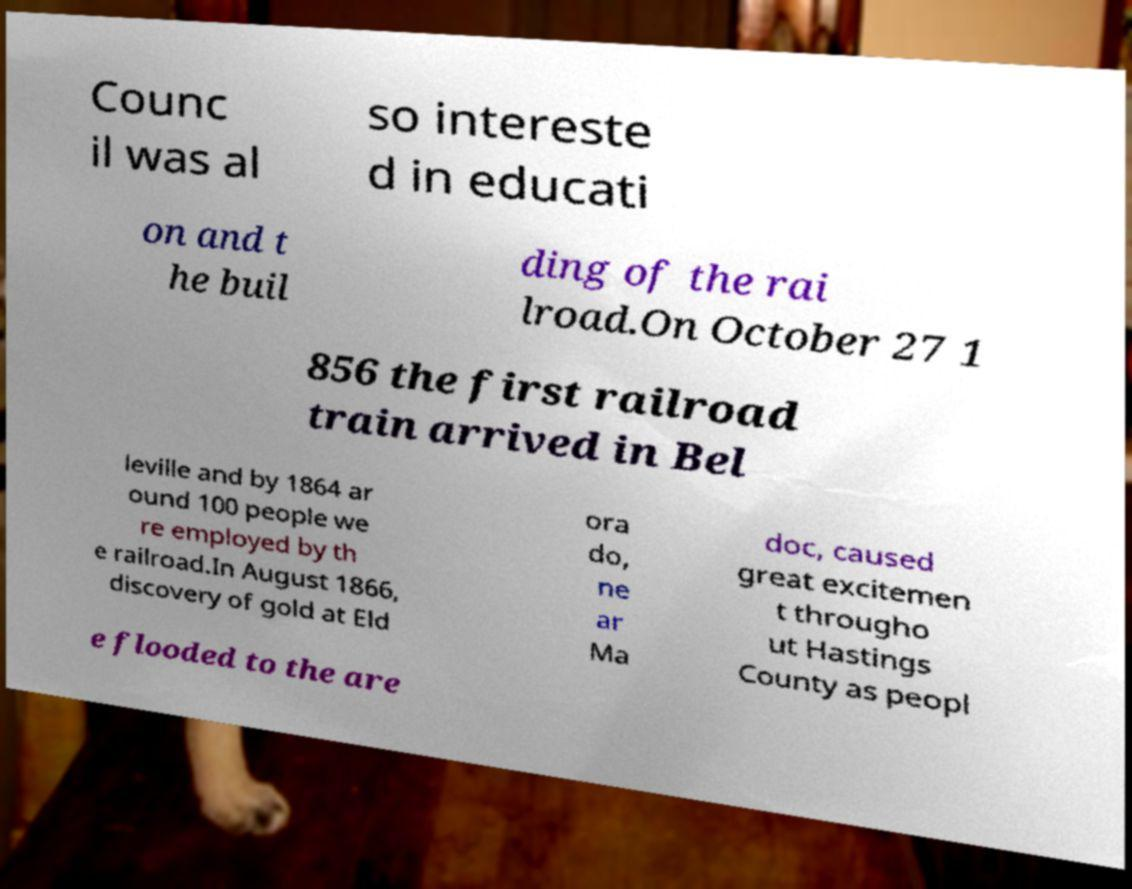Could you assist in decoding the text presented in this image and type it out clearly? Counc il was al so intereste d in educati on and t he buil ding of the rai lroad.On October 27 1 856 the first railroad train arrived in Bel leville and by 1864 ar ound 100 people we re employed by th e railroad.In August 1866, discovery of gold at Eld ora do, ne ar Ma doc, caused great excitemen t througho ut Hastings County as peopl e flooded to the are 